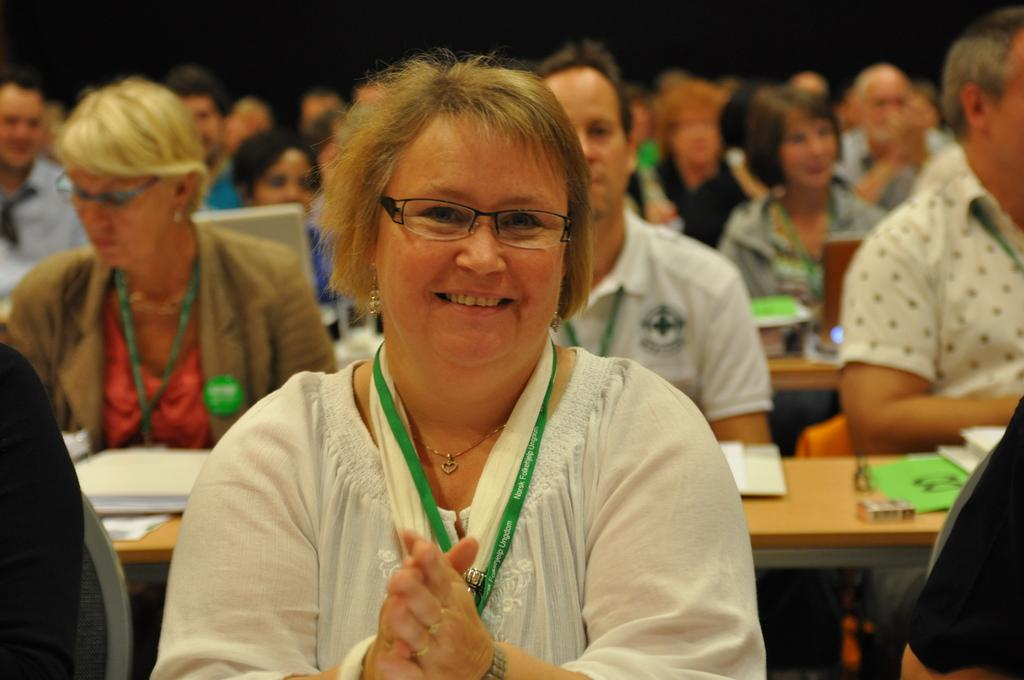What are the persons in the image doing? The persons in the image are sitting on chairs. Where are the chairs located? The chairs are placed at tables. What can be seen on the tables besides the chairs? There are books and laptops on the tables. Are there any other objects on the tables? Yes, there are other objects on the tables. What type of hook can be seen on the laptops in the image? There are no hooks visible on the laptops in the image. What invention is being used by the persons in the image? The laptops and books are visible in the image, but there is no specific invention being used by the persons. 